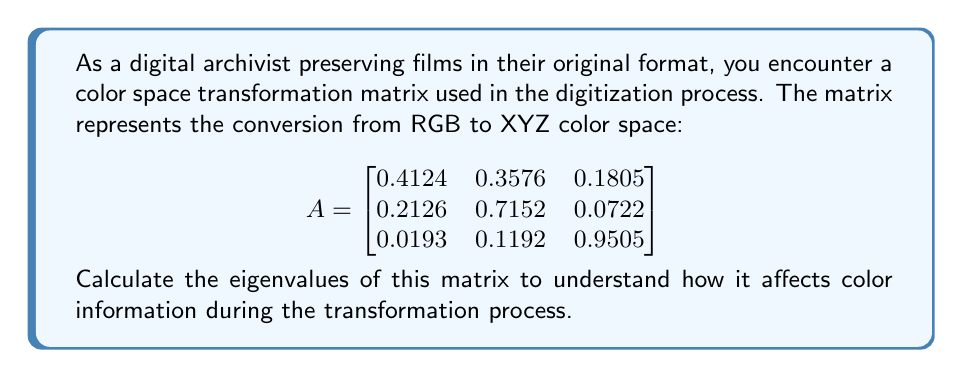What is the answer to this math problem? To find the eigenvalues of matrix A, we need to solve the characteristic equation:

1. Set up the characteristic equation:
   $$det(A - \lambda I) = 0$$
   where I is the 3x3 identity matrix and λ represents the eigenvalues.

2. Expand the determinant:
   $$\begin{vmatrix}
   0.4124 - \lambda & 0.3576 & 0.1805 \\
   0.2126 & 0.7152 - \lambda & 0.0722 \\
   0.0193 & 0.1192 & 0.9505 - \lambda
   \end{vmatrix} = 0$$

3. Calculate the determinant:
   $$(0.4124 - \lambda)[(0.7152 - \lambda)(0.9505 - \lambda) - 0.0722 \cdot 0.1192]$$
   $$- 0.3576[0.2126(0.9505 - \lambda) - 0.0722 \cdot 0.0193]$$
   $$+ 0.1805[0.2126 \cdot 0.1192 - 0.0193(0.7152 - \lambda)] = 0$$

4. Simplify and rearrange to get the characteristic polynomial:
   $$-\lambda^3 + 2.0781\lambda^2 - 1.0855\lambda + 0.0855 = 0$$

5. Solve this cubic equation. The roots of this equation are the eigenvalues.
   Using numerical methods or a computer algebra system, we find the roots:

   $\lambda_1 \approx 1.0000$
   $\lambda_2 \approx 0.9568$
   $\lambda_3 \approx 0.1213$

These eigenvalues represent the scaling factors along the principal axes of the color transformation.
Answer: $\lambda_1 \approx 1.0000$, $\lambda_2 \approx 0.9568$, $\lambda_3 \approx 0.1213$ 